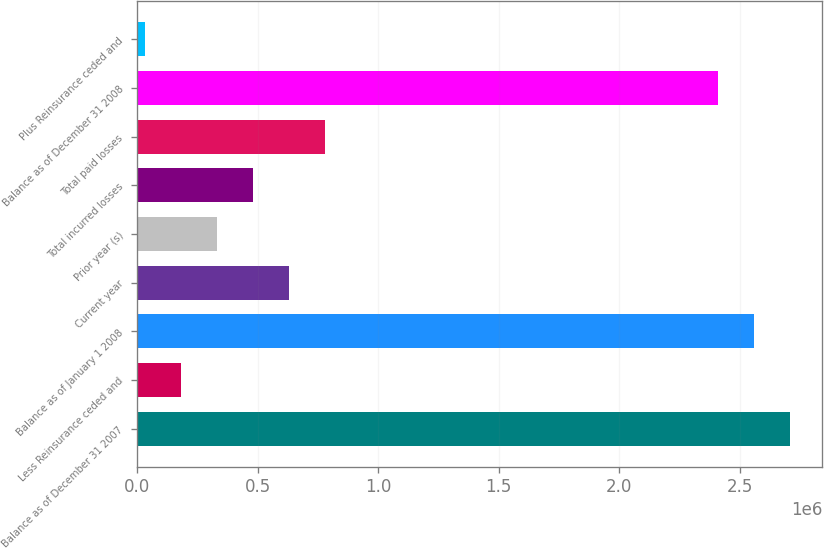Convert chart to OTSL. <chart><loc_0><loc_0><loc_500><loc_500><bar_chart><fcel>Balance as of December 31 2007<fcel>Less Reinsurance ceded and<fcel>Balance as of January 1 2008<fcel>Current year<fcel>Prior year (s)<fcel>Total incurred losses<fcel>Total paid losses<fcel>Balance as of December 31 2008<fcel>Plus Reinsurance ceded and<nl><fcel>2.70784e+06<fcel>184087<fcel>2.55886e+06<fcel>631001<fcel>333058<fcel>482030<fcel>779973<fcel>2.40989e+06<fcel>35115<nl></chart> 